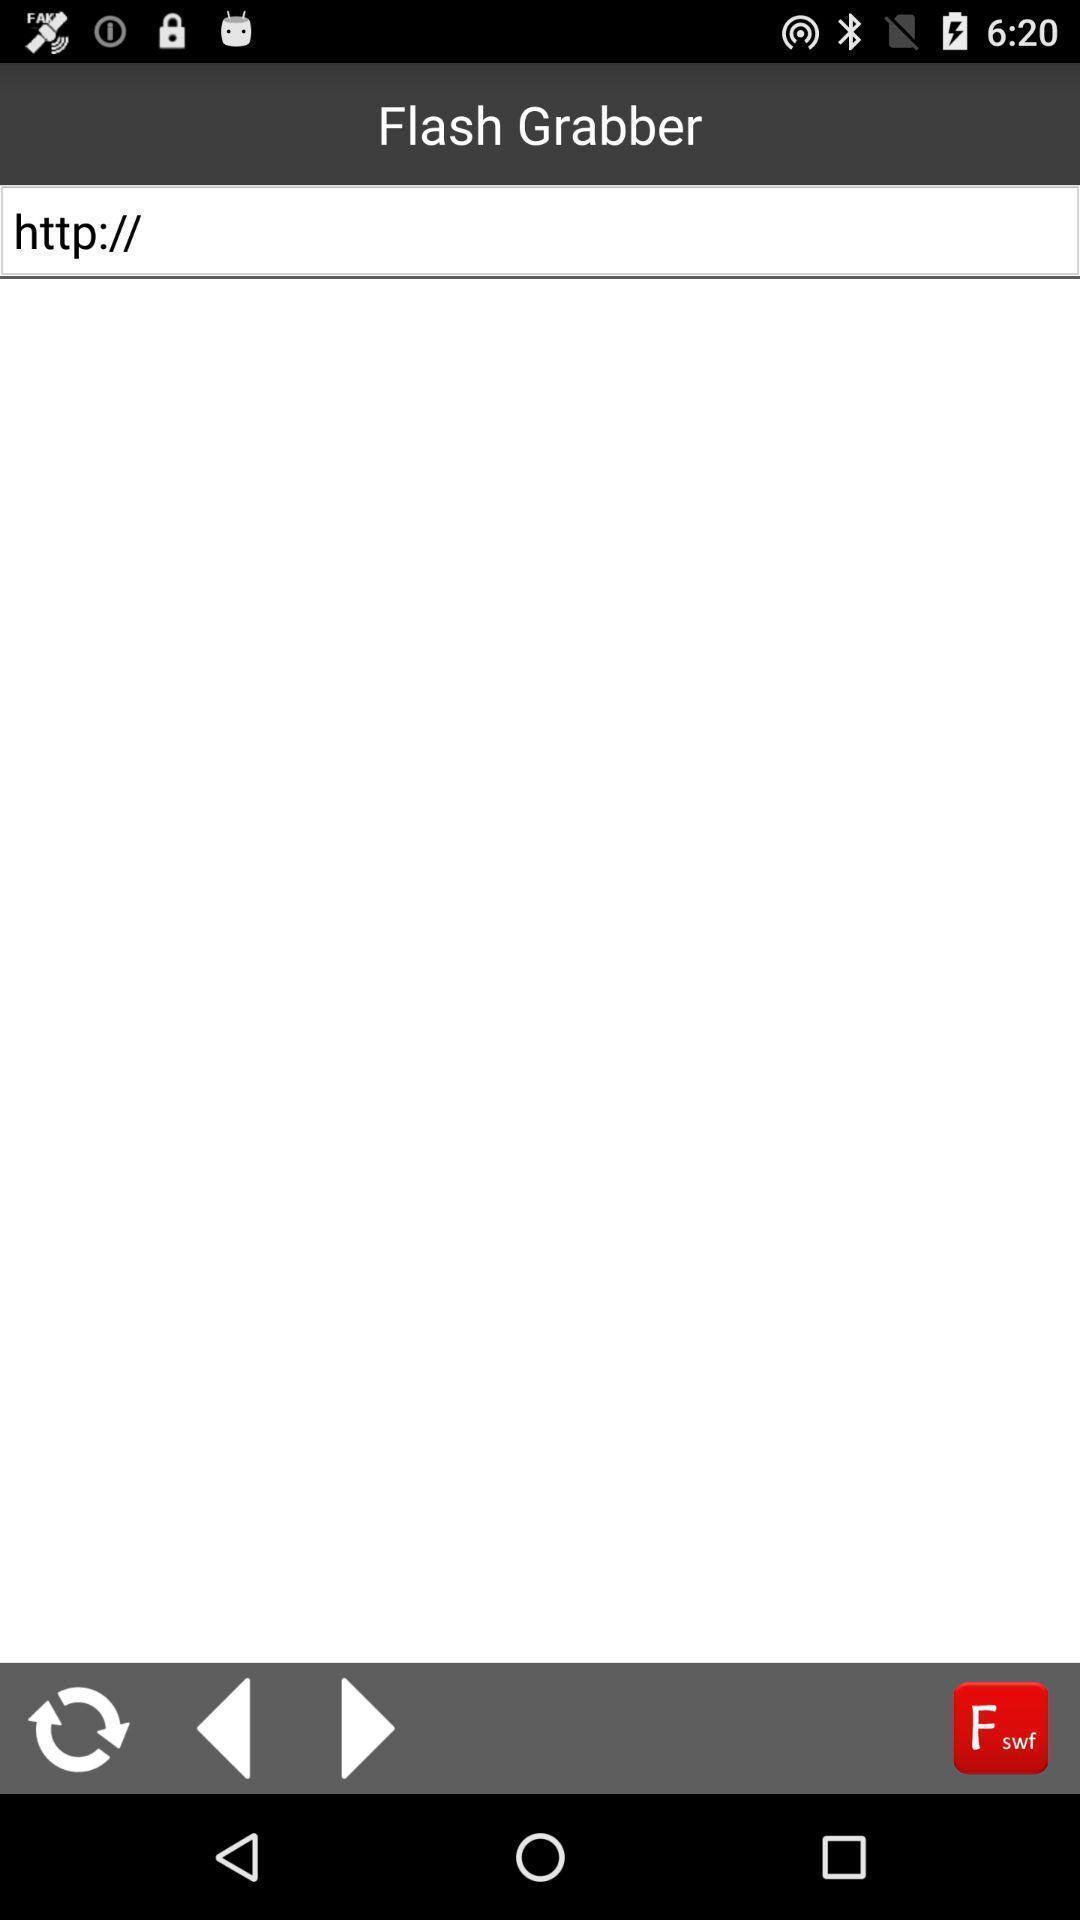Explain the elements present in this screenshot. Page displays the loading site of the social app. 